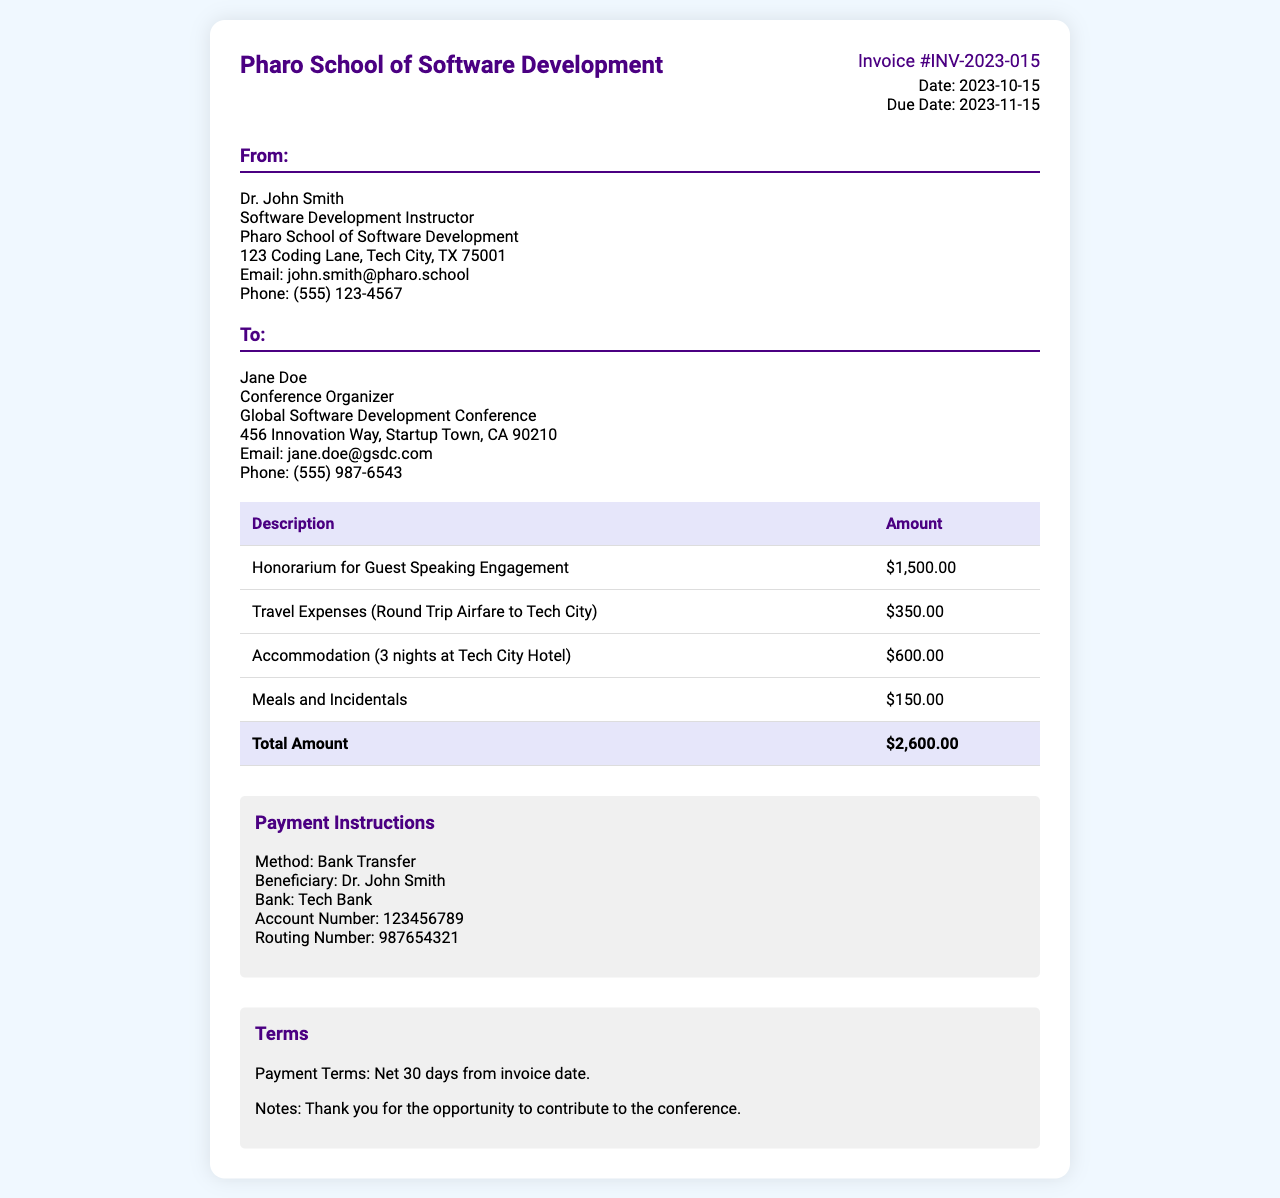What is the invoice number? The invoice number is a unique identifier for the document and can be found prominently in the header section.
Answer: INV-2023-015 Who is the recipient of the invoice? The recipient, also known as the "To" section, contains the name of the person or organization receiving the invoice.
Answer: Jane Doe What is the total amount due? The total amount due is the sum of all costs outlined in the invoice table, listed at the bottom.
Answer: $2,600.00 What date is the invoice due? The due date is specified in the invoice details and indicates when payment is expected.
Answer: 2023-11-15 How much is the honorarium for the guest speaking engagement? The honorarium amount is specified in the invoice table under the description "Honorarium for Guest Speaking Engagement."
Answer: $1,500.00 What is the payment method indicated in the invoice? The payment method describes how the payment is to be made and is outlined in the payment instructions section.
Answer: Bank Transfer How many nights was accommodation booked for? The accommodation duration can be found in the invoice table under the description "Accommodation."
Answer: 3 nights What is the name of the guest speaker? The guest speaker's name can be found in the "From" section at the top of the invoice.
Answer: Dr. John Smith What are the payment terms stated in the invoice? The payment terms refer to the conditions under which the payment must be made and are listed in the terms section of the document.
Answer: Net 30 days from invoice date 